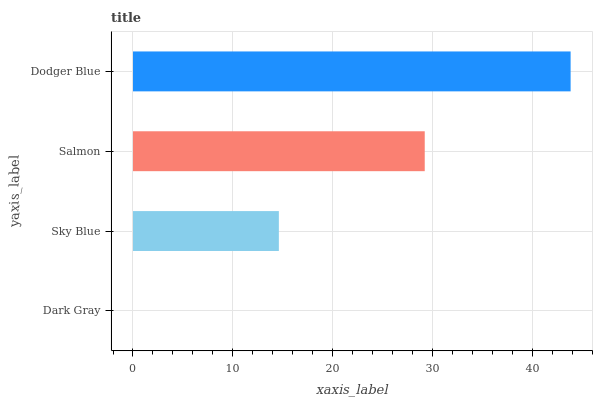Is Dark Gray the minimum?
Answer yes or no. Yes. Is Dodger Blue the maximum?
Answer yes or no. Yes. Is Sky Blue the minimum?
Answer yes or no. No. Is Sky Blue the maximum?
Answer yes or no. No. Is Sky Blue greater than Dark Gray?
Answer yes or no. Yes. Is Dark Gray less than Sky Blue?
Answer yes or no. Yes. Is Dark Gray greater than Sky Blue?
Answer yes or no. No. Is Sky Blue less than Dark Gray?
Answer yes or no. No. Is Salmon the high median?
Answer yes or no. Yes. Is Sky Blue the low median?
Answer yes or no. Yes. Is Dodger Blue the high median?
Answer yes or no. No. Is Dark Gray the low median?
Answer yes or no. No. 